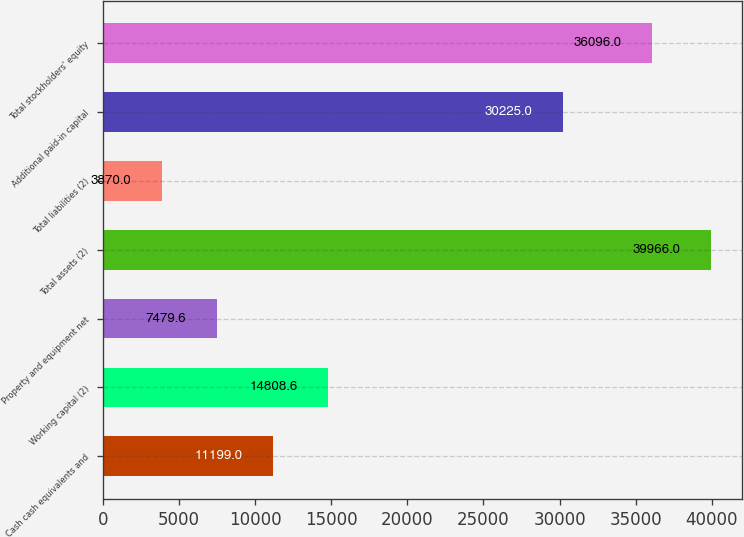Convert chart. <chart><loc_0><loc_0><loc_500><loc_500><bar_chart><fcel>Cash cash equivalents and<fcel>Working capital (2)<fcel>Property and equipment net<fcel>Total assets (2)<fcel>Total liabilities (2)<fcel>Additional paid-in capital<fcel>Total stockholders' equity<nl><fcel>11199<fcel>14808.6<fcel>7479.6<fcel>39966<fcel>3870<fcel>30225<fcel>36096<nl></chart> 